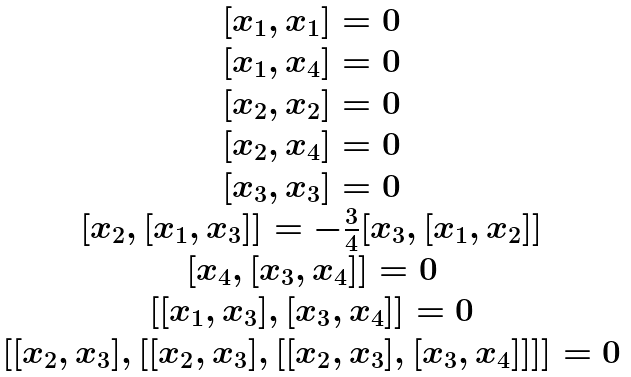<formula> <loc_0><loc_0><loc_500><loc_500>\begin{matrix} { { [ x _ { 1 } , x _ { 1 } ] } = 0 } \\ { { [ x _ { 1 } , x _ { 4 } ] } = 0 } \\ { { [ x _ { 2 } , x _ { 2 } ] } = 0 } \\ { { [ x _ { 2 } , x _ { 4 } ] } = 0 } \\ { { [ x _ { 3 } , x _ { 3 } ] } = 0 } \\ { { [ x _ { 2 } , [ x _ { 1 } , x _ { 3 } ] ] } = { { - \frac { 3 } { 4 } [ x _ { 3 } , [ x _ { 1 } , x _ { 2 } ] ] } } } \\ { { [ x _ { 4 } , [ x _ { 3 } , x _ { 4 } ] ] } = 0 } \\ { { [ [ x _ { 1 } , x _ { 3 } ] , [ x _ { 3 } , x _ { 4 } ] ] } = 0 } \\ { { [ [ x _ { 2 } , x _ { 3 } ] , [ [ x _ { 2 } , x _ { 3 } ] , [ [ x _ { 2 } , x _ { 3 } ] , [ x _ { 3 } , x _ { 4 } ] ] ] ] } = 0 } \end{matrix}</formula> 